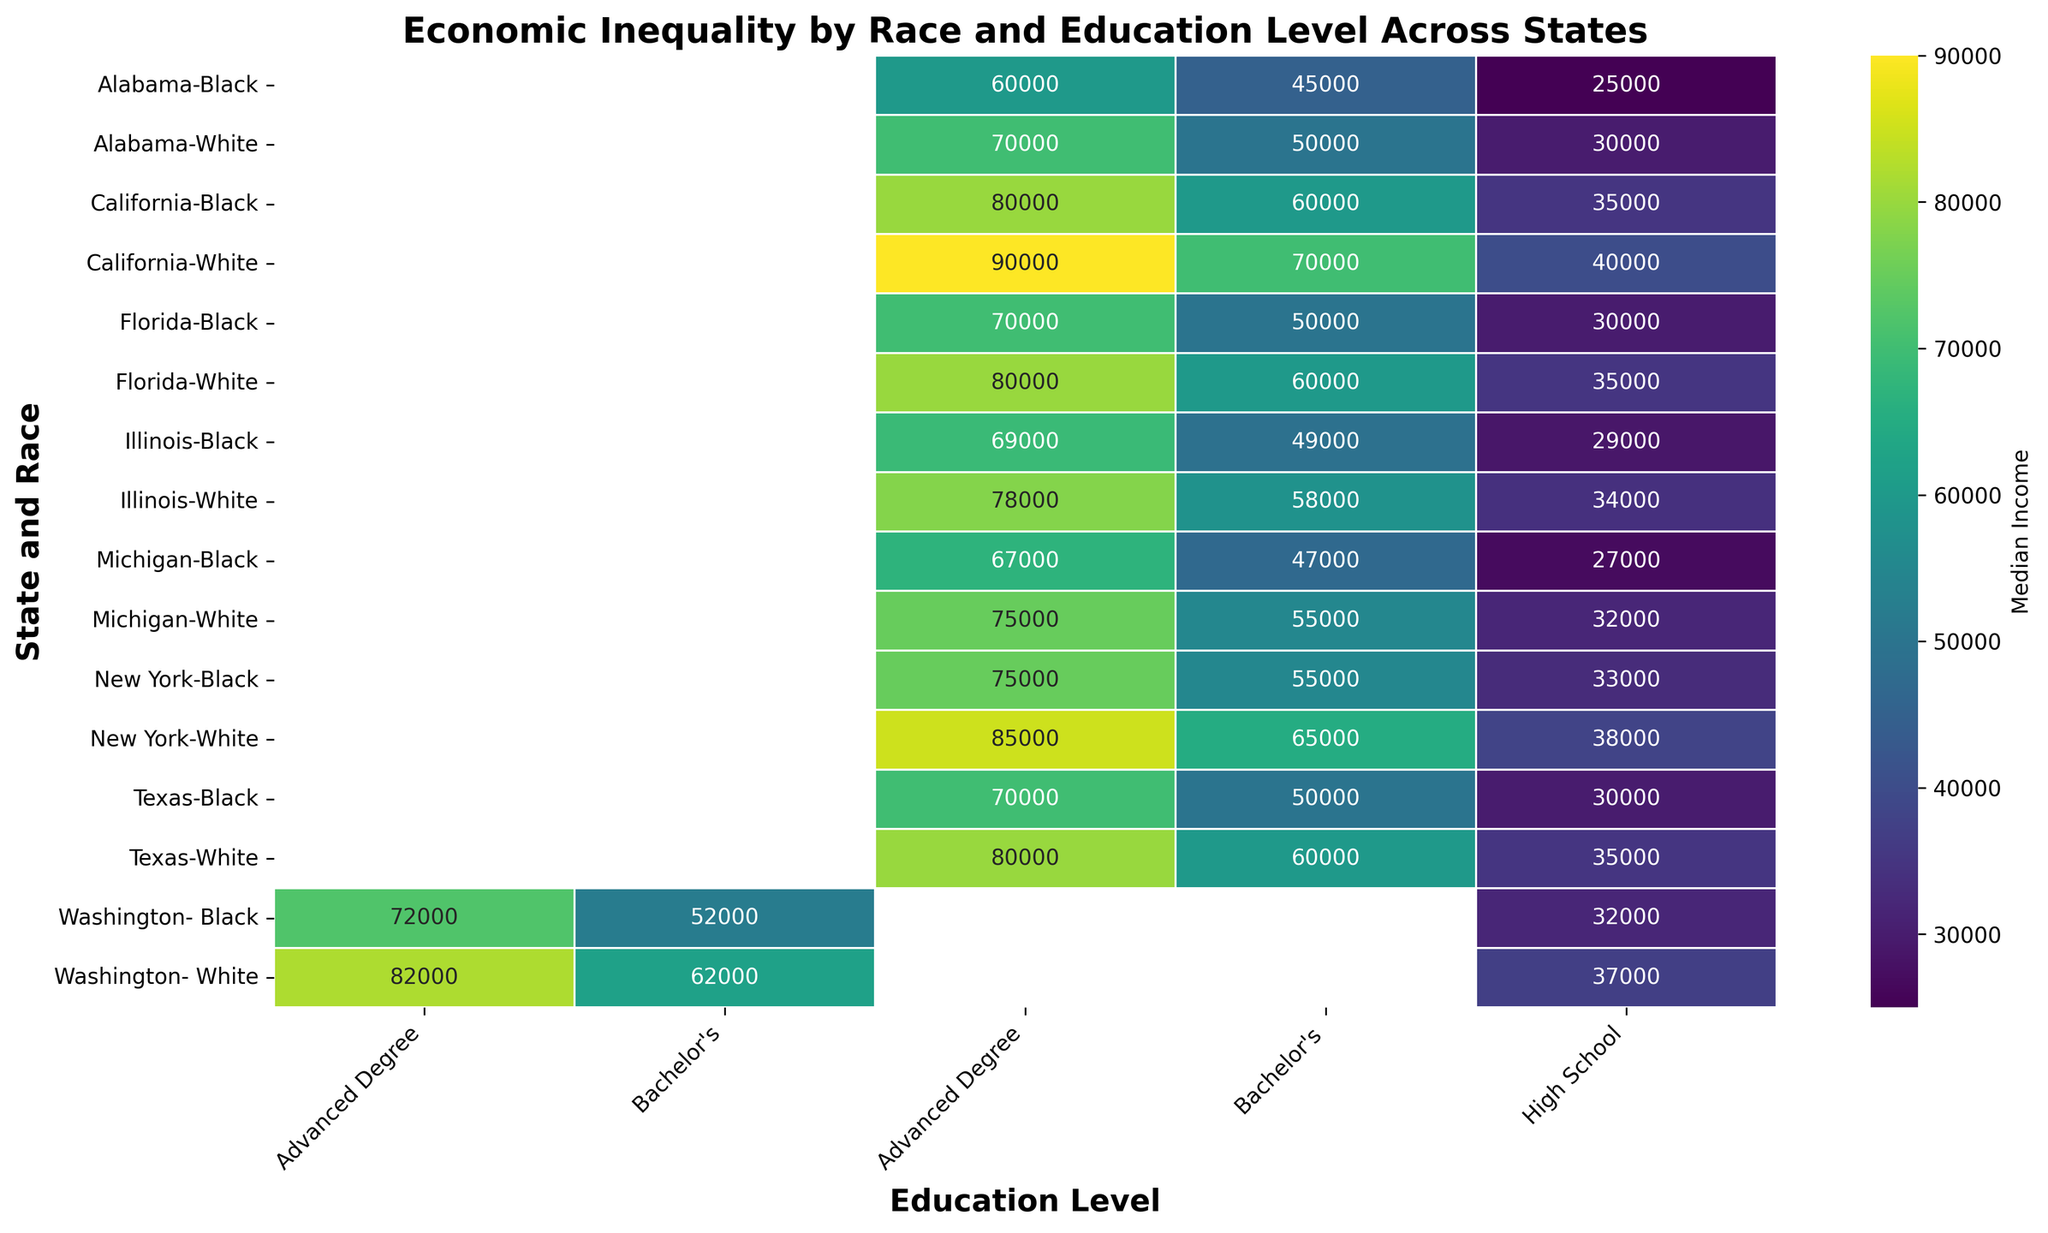What is the median income for Black individuals with advanced degrees in California? To determine this, find the cell corresponding to California, Black, and Advanced Degree, and read the income value.
Answer: 80000 Which race in Texas has a higher median income with a Bachelor's degree? Compare the median incomes in Texas for White and Black individuals with a Bachelor's degree. White individuals have a median income of 60000, while Black individuals have a median income of 50000.
Answer: White What is the difference in median income between White and Black individuals with high school diplomas in Illinois? Find the values for White and Black individuals with high school diplomas in Illinois, which are 34000 and 29000, respectively. Subtract the smaller value from the larger value (34000 - 29000).
Answer: 5000 Which State has the highest median income for White individuals with a Bachelor's degree? Look for the highest value in the bachelor's degree column for White individuals across different states. The highest value is for California, which is 70000.
Answer: California What is the average median income for Black individuals with a Bachelor's degree across all states? Sum the median incomes for Black individuals with Bachelor's degrees across all states (45000 + 60000 + 50000 + 55000 + 50000 + 52000 + 47000 + 49000) and divide by the number of states (8). The sum is 408000, and dividing by 8 gives 51000.
Answer: 51000 